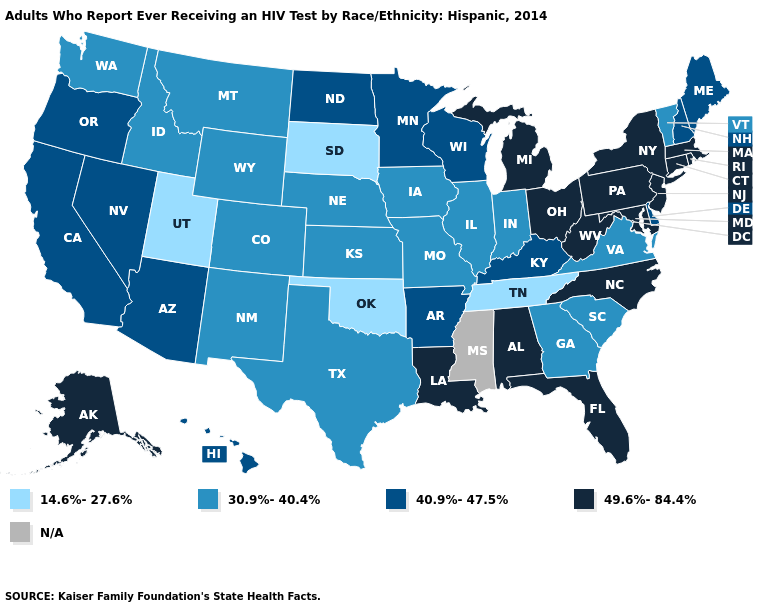Which states hav the highest value in the West?
Keep it brief. Alaska. Among the states that border Arkansas , does Missouri have the highest value?
Short answer required. No. Which states have the highest value in the USA?
Write a very short answer. Alabama, Alaska, Connecticut, Florida, Louisiana, Maryland, Massachusetts, Michigan, New Jersey, New York, North Carolina, Ohio, Pennsylvania, Rhode Island, West Virginia. Among the states that border Mississippi , which have the lowest value?
Give a very brief answer. Tennessee. Among the states that border New York , which have the lowest value?
Concise answer only. Vermont. Among the states that border New Mexico , which have the lowest value?
Answer briefly. Oklahoma, Utah. What is the value of Kentucky?
Short answer required. 40.9%-47.5%. Does the map have missing data?
Give a very brief answer. Yes. What is the lowest value in the South?
Keep it brief. 14.6%-27.6%. What is the value of Washington?
Short answer required. 30.9%-40.4%. Among the states that border Georgia , which have the lowest value?
Write a very short answer. Tennessee. Name the states that have a value in the range 49.6%-84.4%?
Give a very brief answer. Alabama, Alaska, Connecticut, Florida, Louisiana, Maryland, Massachusetts, Michigan, New Jersey, New York, North Carolina, Ohio, Pennsylvania, Rhode Island, West Virginia. Name the states that have a value in the range 49.6%-84.4%?
Concise answer only. Alabama, Alaska, Connecticut, Florida, Louisiana, Maryland, Massachusetts, Michigan, New Jersey, New York, North Carolina, Ohio, Pennsylvania, Rhode Island, West Virginia. 